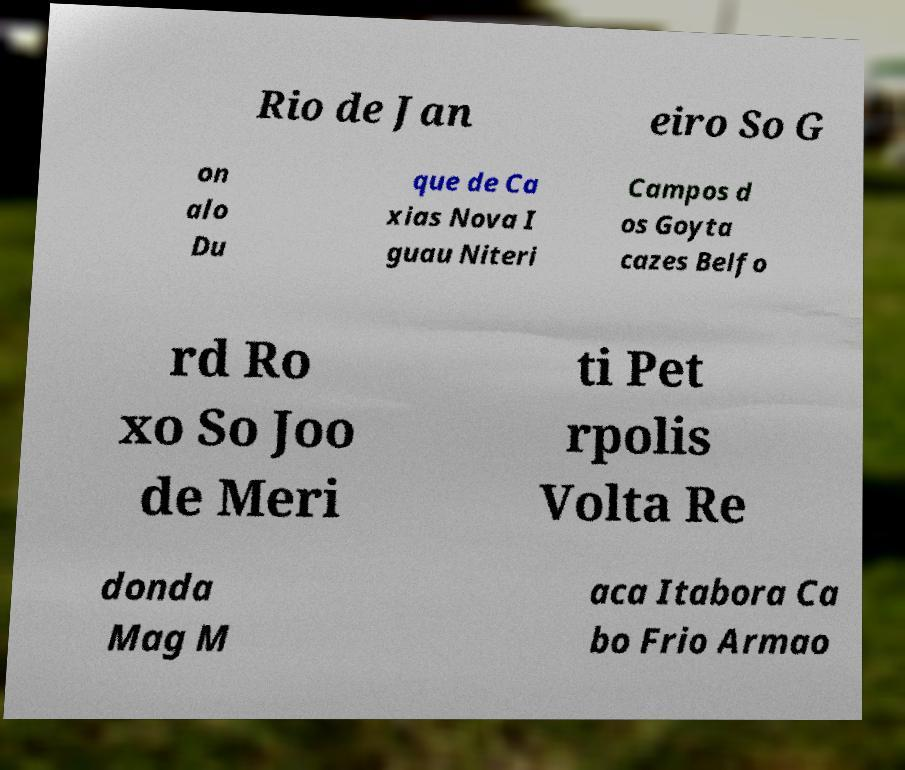Can you read and provide the text displayed in the image?This photo seems to have some interesting text. Can you extract and type it out for me? Rio de Jan eiro So G on alo Du que de Ca xias Nova I guau Niteri Campos d os Goyta cazes Belfo rd Ro xo So Joo de Meri ti Pet rpolis Volta Re donda Mag M aca Itabora Ca bo Frio Armao 